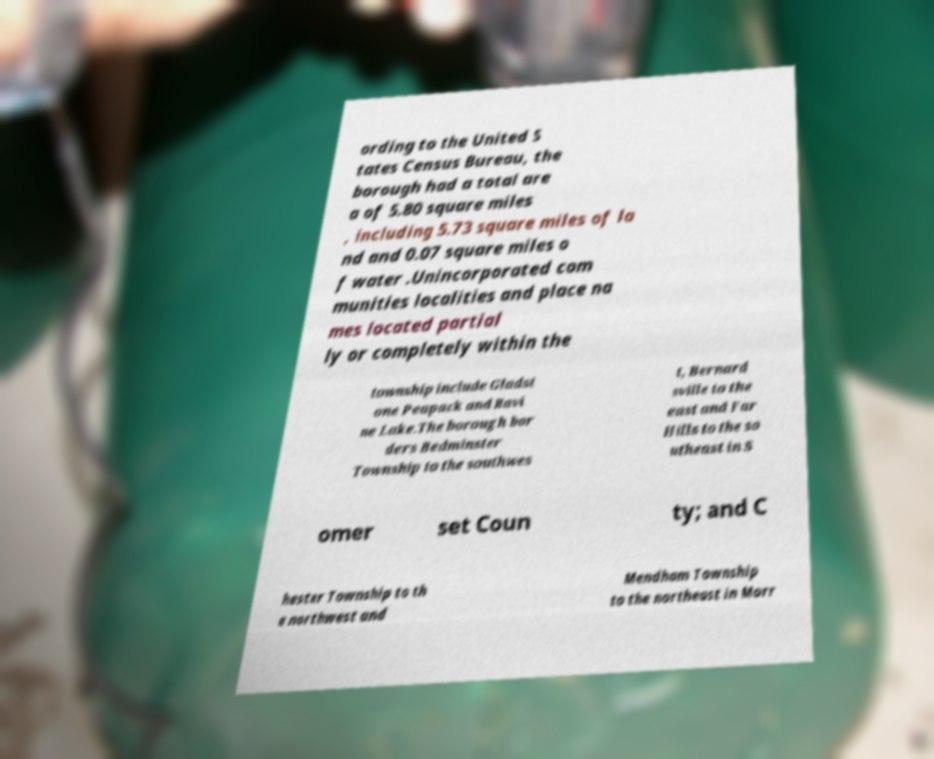Can you read and provide the text displayed in the image?This photo seems to have some interesting text. Can you extract and type it out for me? ording to the United S tates Census Bureau, the borough had a total are a of 5.80 square miles , including 5.73 square miles of la nd and 0.07 square miles o f water .Unincorporated com munities localities and place na mes located partial ly or completely within the township include Gladst one Peapack and Ravi ne Lake.The borough bor ders Bedminster Township to the southwes t, Bernard sville to the east and Far Hills to the so utheast in S omer set Coun ty; and C hester Township to th e northwest and Mendham Township to the northeast in Morr 